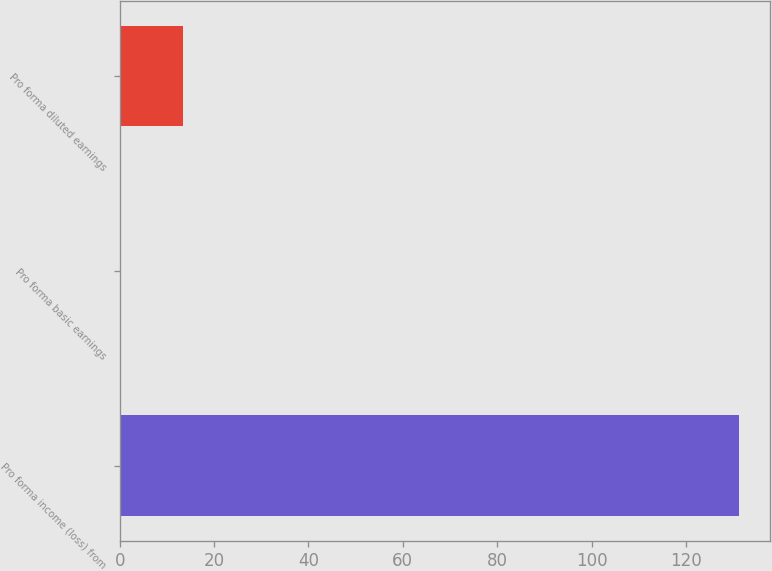Convert chart. <chart><loc_0><loc_0><loc_500><loc_500><bar_chart><fcel>Pro forma income (loss) from<fcel>Pro forma basic earnings<fcel>Pro forma diluted earnings<nl><fcel>131.3<fcel>0.25<fcel>13.36<nl></chart> 